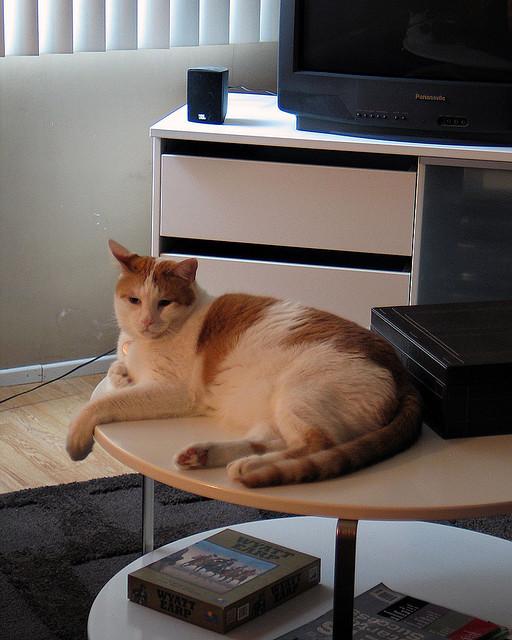Is there a TV?
Be succinct. Yes. What color is the cat?
Write a very short answer. Orange and white. Is the cat sleeping?
Write a very short answer. No. What is the cat sleeping on?
Give a very brief answer. Table. 